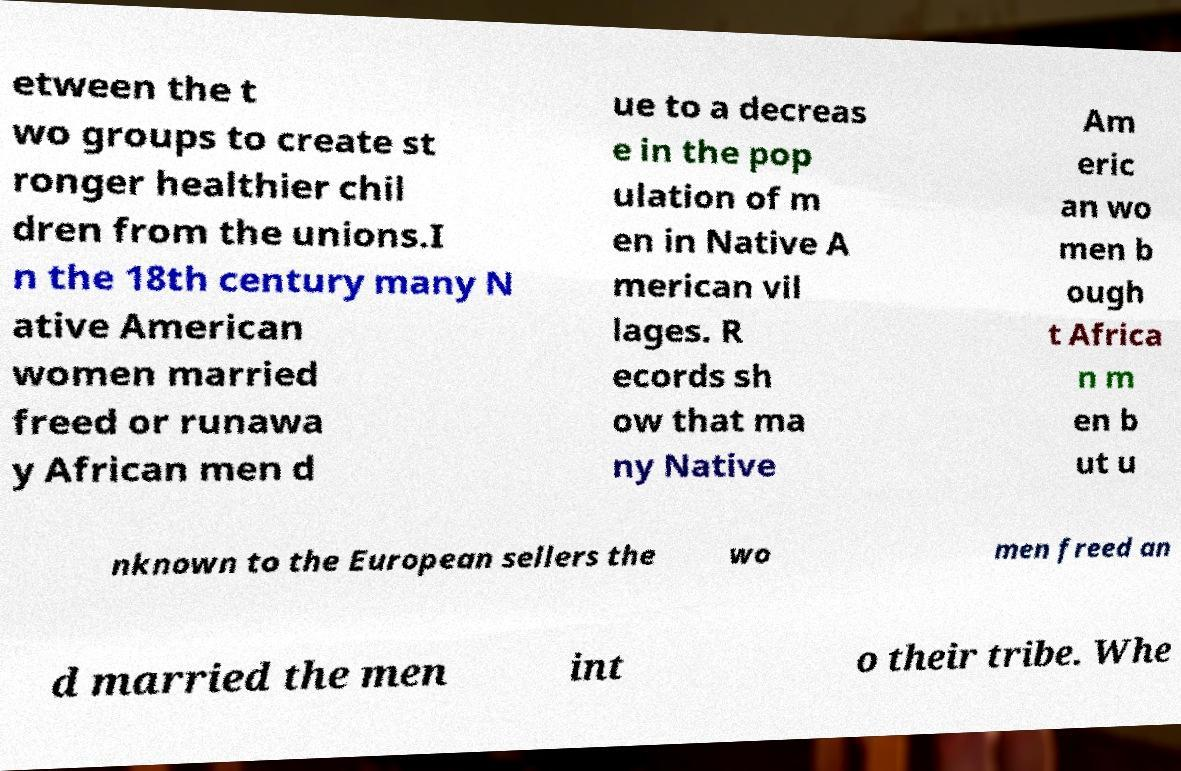Could you extract and type out the text from this image? etween the t wo groups to create st ronger healthier chil dren from the unions.I n the 18th century many N ative American women married freed or runawa y African men d ue to a decreas e in the pop ulation of m en in Native A merican vil lages. R ecords sh ow that ma ny Native Am eric an wo men b ough t Africa n m en b ut u nknown to the European sellers the wo men freed an d married the men int o their tribe. Whe 